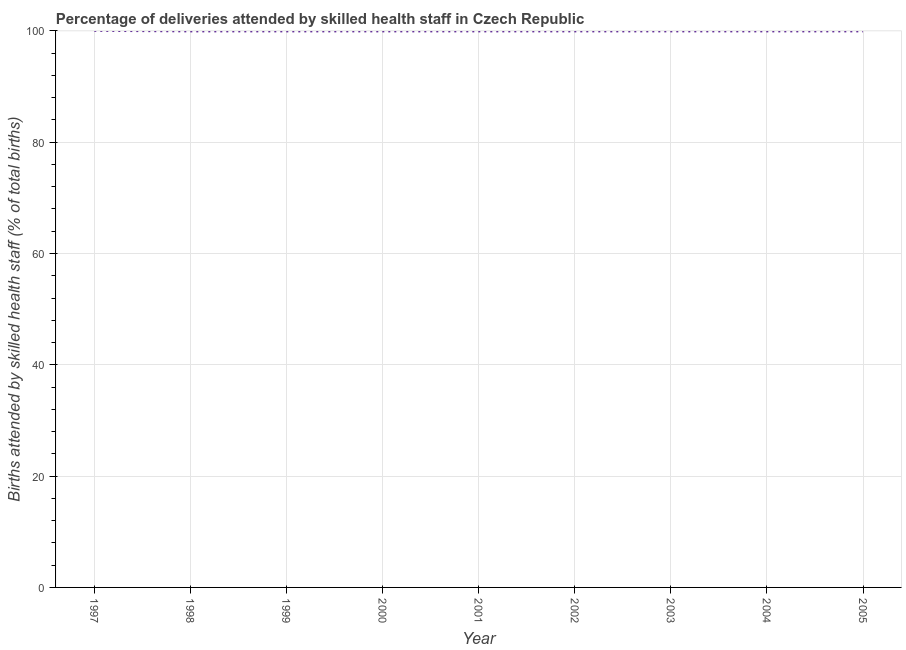What is the number of births attended by skilled health staff in 2004?
Provide a short and direct response. 99.9. Across all years, what is the maximum number of births attended by skilled health staff?
Your answer should be very brief. 100. Across all years, what is the minimum number of births attended by skilled health staff?
Provide a succinct answer. 99.9. In which year was the number of births attended by skilled health staff maximum?
Make the answer very short. 1997. What is the sum of the number of births attended by skilled health staff?
Provide a succinct answer. 899.2. What is the difference between the number of births attended by skilled health staff in 1997 and 2000?
Ensure brevity in your answer.  0.1. What is the average number of births attended by skilled health staff per year?
Ensure brevity in your answer.  99.91. What is the median number of births attended by skilled health staff?
Your response must be concise. 99.9. In how many years, is the number of births attended by skilled health staff greater than 68 %?
Ensure brevity in your answer.  9. Do a majority of the years between 2004 and 1997 (inclusive) have number of births attended by skilled health staff greater than 8 %?
Your response must be concise. Yes. Is the number of births attended by skilled health staff in 1997 less than that in 2005?
Make the answer very short. No. Is the difference between the number of births attended by skilled health staff in 1998 and 2002 greater than the difference between any two years?
Your answer should be compact. No. What is the difference between the highest and the second highest number of births attended by skilled health staff?
Your answer should be compact. 0.1. Is the sum of the number of births attended by skilled health staff in 1999 and 2001 greater than the maximum number of births attended by skilled health staff across all years?
Your answer should be compact. Yes. What is the difference between the highest and the lowest number of births attended by skilled health staff?
Your answer should be compact. 0.1. How many lines are there?
Ensure brevity in your answer.  1. What is the difference between two consecutive major ticks on the Y-axis?
Your response must be concise. 20. Are the values on the major ticks of Y-axis written in scientific E-notation?
Offer a very short reply. No. What is the title of the graph?
Your response must be concise. Percentage of deliveries attended by skilled health staff in Czech Republic. What is the label or title of the X-axis?
Provide a succinct answer. Year. What is the label or title of the Y-axis?
Keep it short and to the point. Births attended by skilled health staff (% of total births). What is the Births attended by skilled health staff (% of total births) of 1997?
Provide a succinct answer. 100. What is the Births attended by skilled health staff (% of total births) in 1998?
Offer a terse response. 99.9. What is the Births attended by skilled health staff (% of total births) of 1999?
Give a very brief answer. 99.9. What is the Births attended by skilled health staff (% of total births) in 2000?
Ensure brevity in your answer.  99.9. What is the Births attended by skilled health staff (% of total births) of 2001?
Your answer should be very brief. 99.9. What is the Births attended by skilled health staff (% of total births) in 2002?
Your answer should be very brief. 99.9. What is the Births attended by skilled health staff (% of total births) of 2003?
Provide a succinct answer. 99.9. What is the Births attended by skilled health staff (% of total births) in 2004?
Provide a short and direct response. 99.9. What is the Births attended by skilled health staff (% of total births) of 2005?
Make the answer very short. 99.9. What is the difference between the Births attended by skilled health staff (% of total births) in 1997 and 1999?
Keep it short and to the point. 0.1. What is the difference between the Births attended by skilled health staff (% of total births) in 1997 and 2000?
Offer a terse response. 0.1. What is the difference between the Births attended by skilled health staff (% of total births) in 1997 and 2001?
Ensure brevity in your answer.  0.1. What is the difference between the Births attended by skilled health staff (% of total births) in 1997 and 2002?
Offer a terse response. 0.1. What is the difference between the Births attended by skilled health staff (% of total births) in 1997 and 2003?
Your answer should be compact. 0.1. What is the difference between the Births attended by skilled health staff (% of total births) in 1997 and 2005?
Your response must be concise. 0.1. What is the difference between the Births attended by skilled health staff (% of total births) in 1998 and 2003?
Provide a succinct answer. 0. What is the difference between the Births attended by skilled health staff (% of total births) in 1998 and 2005?
Offer a very short reply. 0. What is the difference between the Births attended by skilled health staff (% of total births) in 1999 and 2000?
Give a very brief answer. 0. What is the difference between the Births attended by skilled health staff (% of total births) in 1999 and 2001?
Give a very brief answer. 0. What is the difference between the Births attended by skilled health staff (% of total births) in 1999 and 2002?
Offer a very short reply. 0. What is the difference between the Births attended by skilled health staff (% of total births) in 1999 and 2003?
Ensure brevity in your answer.  0. What is the difference between the Births attended by skilled health staff (% of total births) in 1999 and 2005?
Offer a terse response. 0. What is the difference between the Births attended by skilled health staff (% of total births) in 2000 and 2001?
Offer a terse response. 0. What is the difference between the Births attended by skilled health staff (% of total births) in 2000 and 2003?
Your response must be concise. 0. What is the difference between the Births attended by skilled health staff (% of total births) in 2001 and 2002?
Make the answer very short. 0. What is the difference between the Births attended by skilled health staff (% of total births) in 2001 and 2003?
Ensure brevity in your answer.  0. What is the difference between the Births attended by skilled health staff (% of total births) in 2001 and 2004?
Make the answer very short. 0. What is the difference between the Births attended by skilled health staff (% of total births) in 2002 and 2003?
Keep it short and to the point. 0. What is the difference between the Births attended by skilled health staff (% of total births) in 2003 and 2004?
Ensure brevity in your answer.  0. What is the ratio of the Births attended by skilled health staff (% of total births) in 1997 to that in 1998?
Your answer should be very brief. 1. What is the ratio of the Births attended by skilled health staff (% of total births) in 1997 to that in 2000?
Your answer should be very brief. 1. What is the ratio of the Births attended by skilled health staff (% of total births) in 1997 to that in 2001?
Keep it short and to the point. 1. What is the ratio of the Births attended by skilled health staff (% of total births) in 1997 to that in 2002?
Offer a terse response. 1. What is the ratio of the Births attended by skilled health staff (% of total births) in 1997 to that in 2004?
Ensure brevity in your answer.  1. What is the ratio of the Births attended by skilled health staff (% of total births) in 1998 to that in 1999?
Make the answer very short. 1. What is the ratio of the Births attended by skilled health staff (% of total births) in 1998 to that in 2005?
Keep it short and to the point. 1. What is the ratio of the Births attended by skilled health staff (% of total births) in 1999 to that in 2000?
Your answer should be compact. 1. What is the ratio of the Births attended by skilled health staff (% of total births) in 1999 to that in 2001?
Your answer should be very brief. 1. What is the ratio of the Births attended by skilled health staff (% of total births) in 1999 to that in 2002?
Your answer should be compact. 1. What is the ratio of the Births attended by skilled health staff (% of total births) in 1999 to that in 2003?
Your answer should be compact. 1. What is the ratio of the Births attended by skilled health staff (% of total births) in 1999 to that in 2004?
Offer a very short reply. 1. What is the ratio of the Births attended by skilled health staff (% of total births) in 2000 to that in 2001?
Make the answer very short. 1. What is the ratio of the Births attended by skilled health staff (% of total births) in 2000 to that in 2003?
Provide a short and direct response. 1. What is the ratio of the Births attended by skilled health staff (% of total births) in 2000 to that in 2004?
Make the answer very short. 1. What is the ratio of the Births attended by skilled health staff (% of total births) in 2001 to that in 2002?
Keep it short and to the point. 1. What is the ratio of the Births attended by skilled health staff (% of total births) in 2001 to that in 2003?
Provide a short and direct response. 1. What is the ratio of the Births attended by skilled health staff (% of total births) in 2001 to that in 2005?
Make the answer very short. 1. What is the ratio of the Births attended by skilled health staff (% of total births) in 2002 to that in 2004?
Your answer should be very brief. 1. What is the ratio of the Births attended by skilled health staff (% of total births) in 2003 to that in 2004?
Your answer should be very brief. 1. 